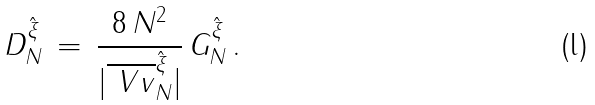Convert formula to latex. <formula><loc_0><loc_0><loc_500><loc_500>D ^ { \hat { \xi } } _ { N } \, = \, \frac { 8 \, N ^ { 2 } } { | \overline { \ V v } ^ { \hat { \xi } } _ { N } | } \, G ^ { \hat { \xi } } _ { N } \, .</formula> 